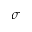Convert formula to latex. <formula><loc_0><loc_0><loc_500><loc_500>\sigma</formula> 